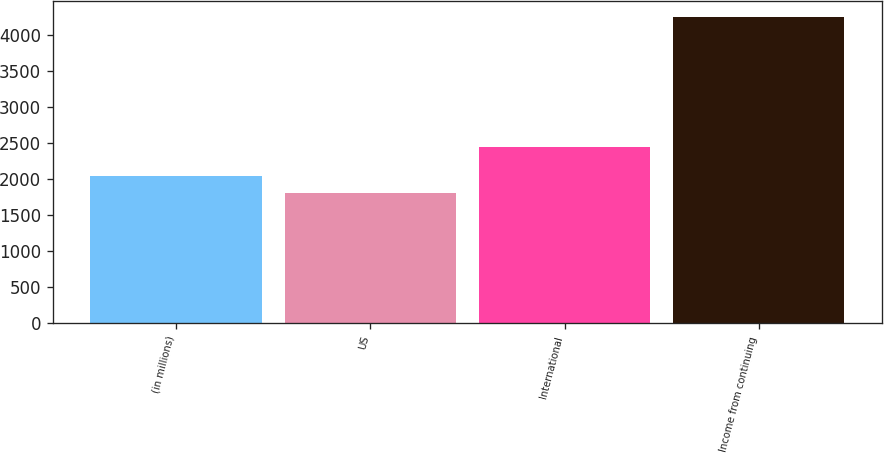<chart> <loc_0><loc_0><loc_500><loc_500><bar_chart><fcel>(in millions)<fcel>US<fcel>International<fcel>Income from continuing<nl><fcel>2050.5<fcel>1806<fcel>2445<fcel>4251<nl></chart> 